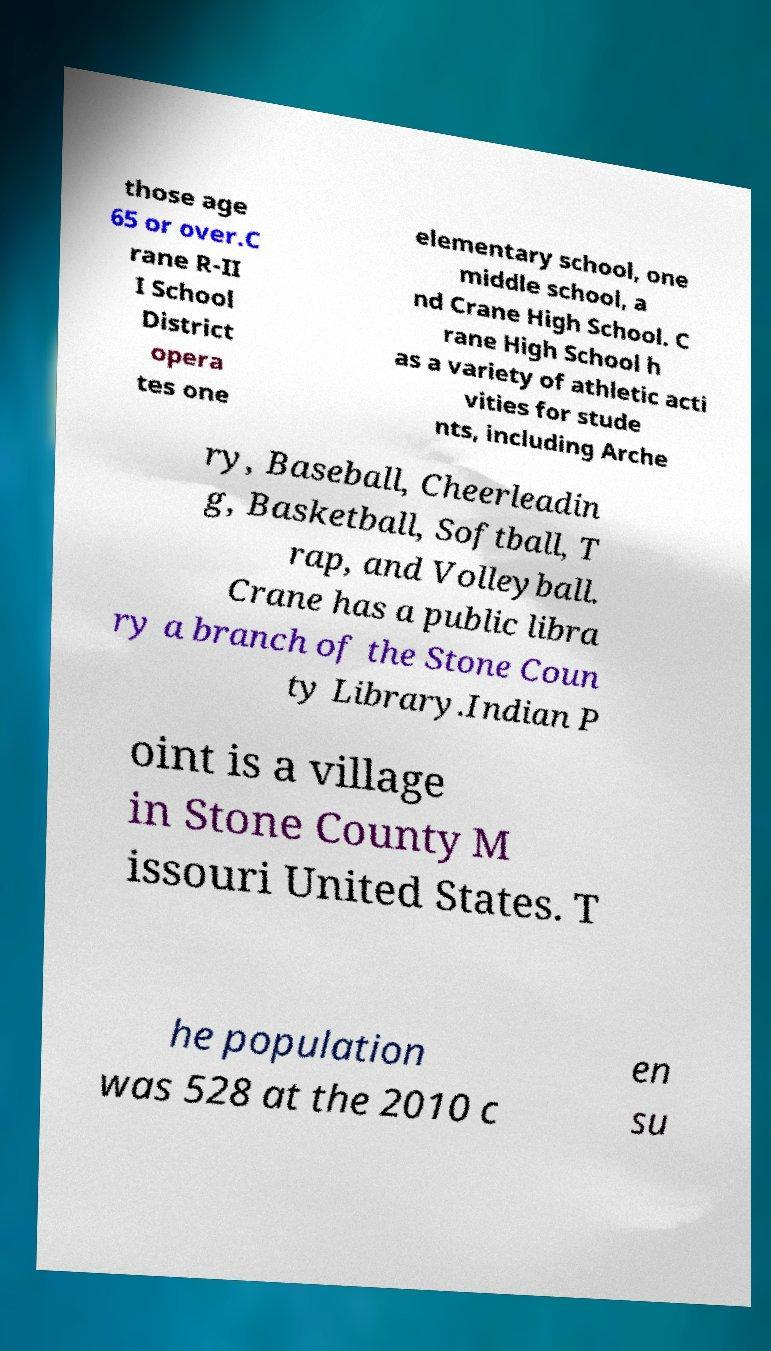Could you assist in decoding the text presented in this image and type it out clearly? those age 65 or over.C rane R-II I School District opera tes one elementary school, one middle school, a nd Crane High School. C rane High School h as a variety of athletic acti vities for stude nts, including Arche ry, Baseball, Cheerleadin g, Basketball, Softball, T rap, and Volleyball. Crane has a public libra ry a branch of the Stone Coun ty Library.Indian P oint is a village in Stone County M issouri United States. T he population was 528 at the 2010 c en su 